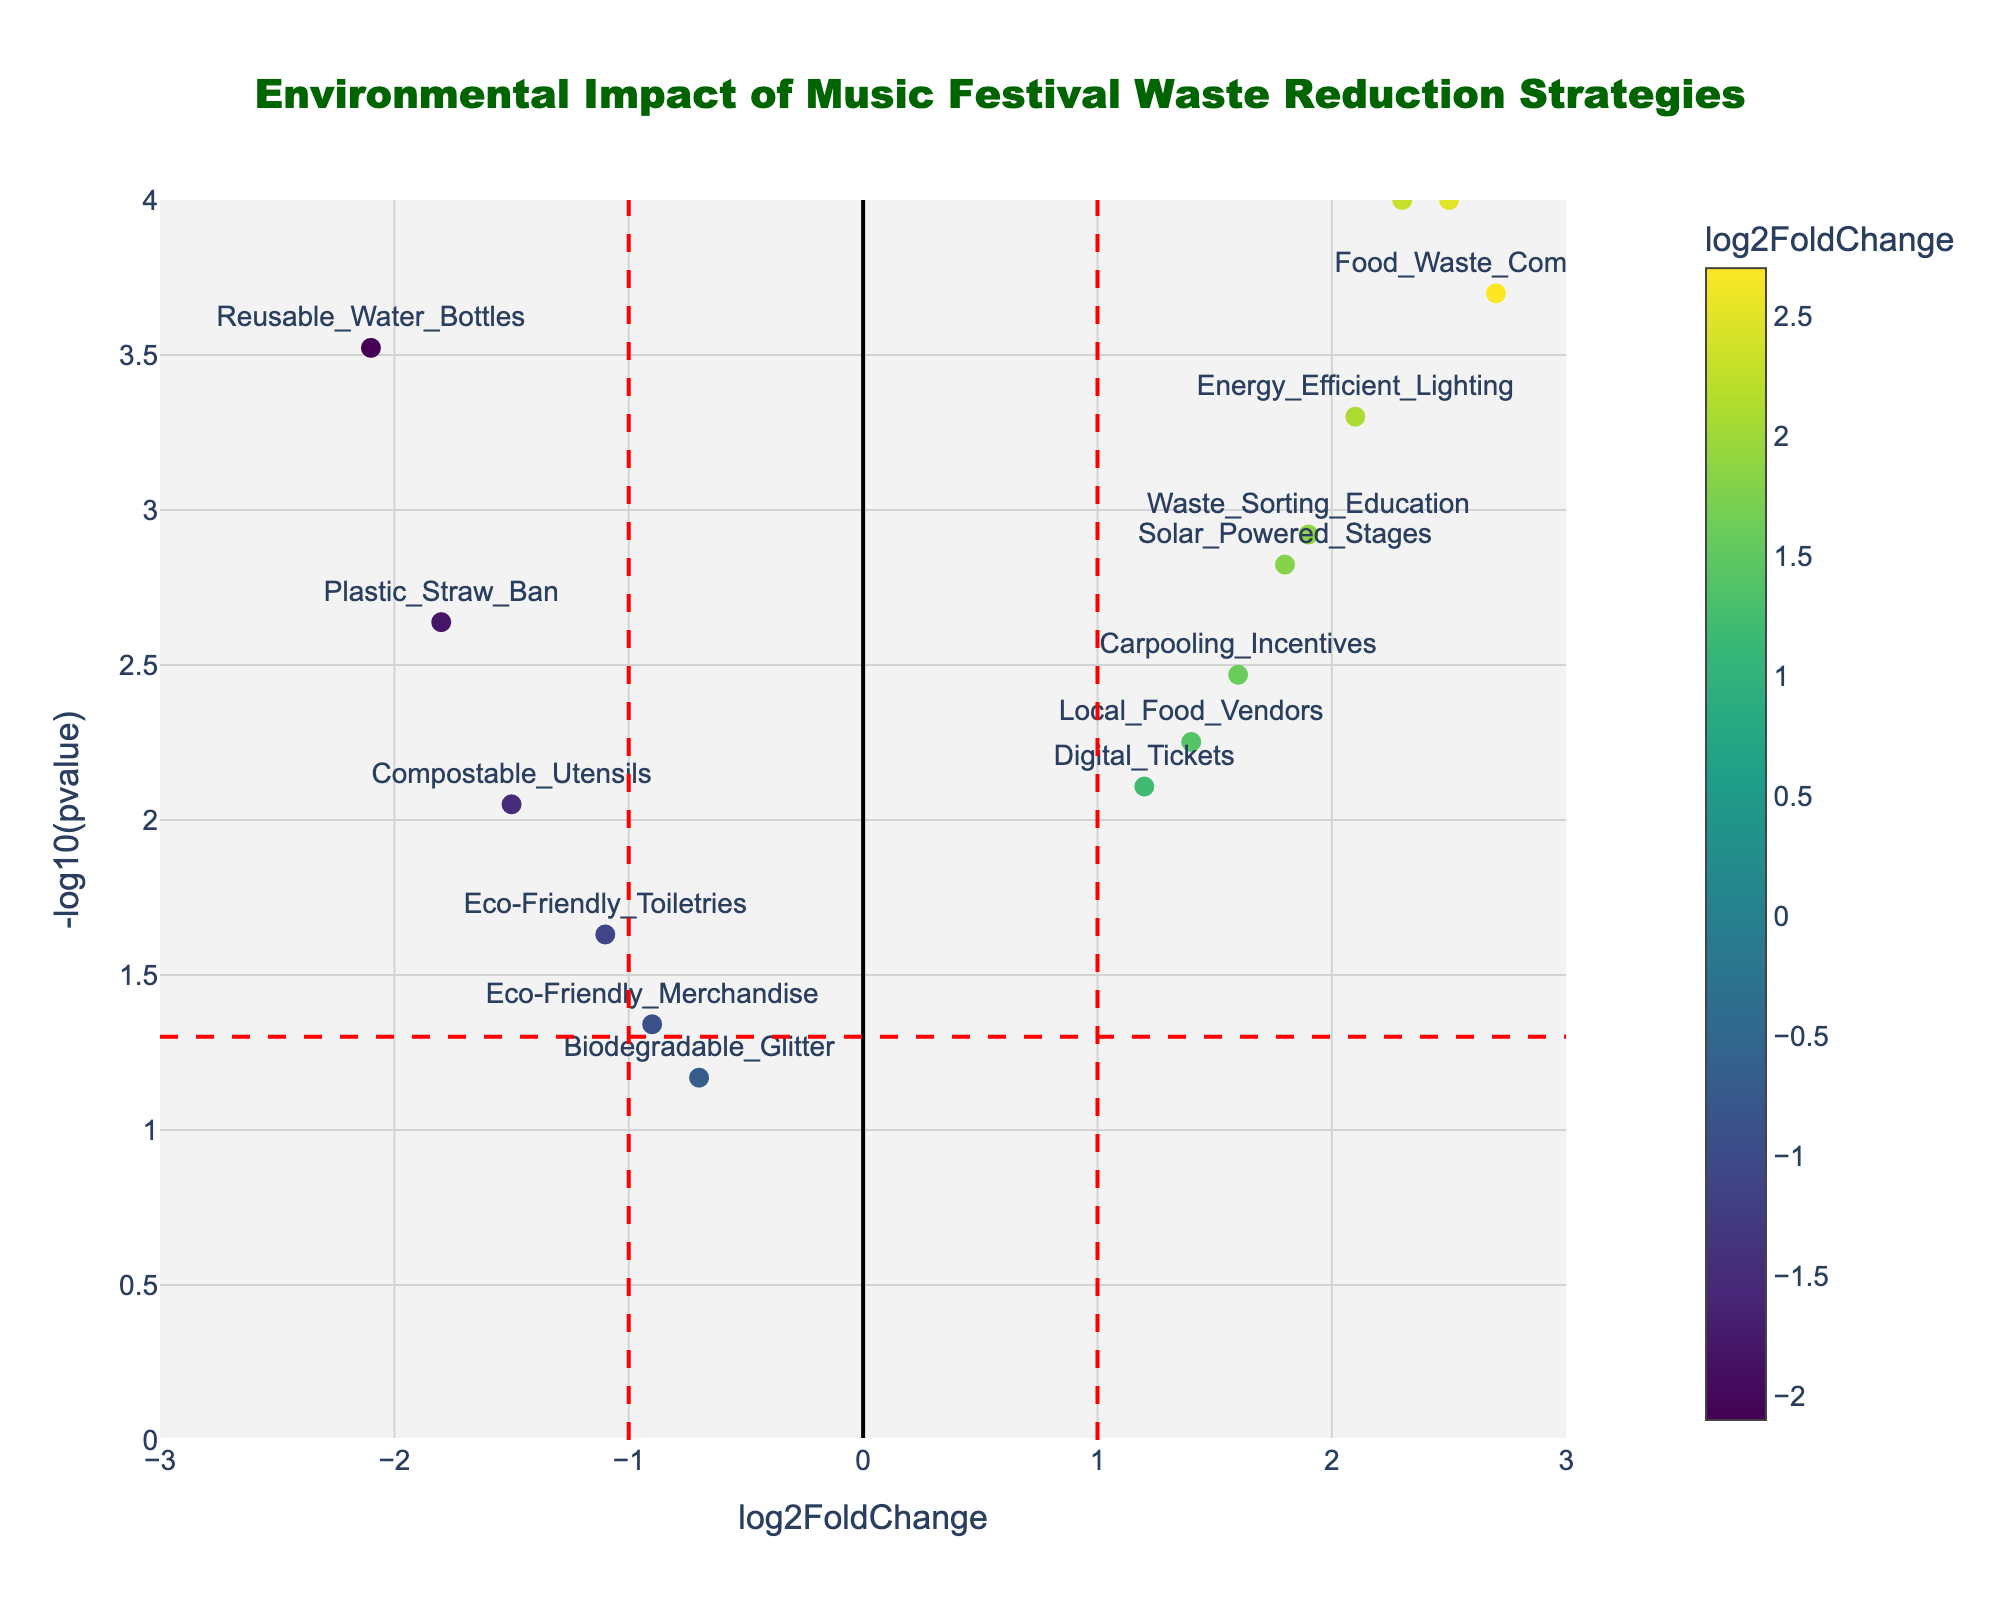What is the title of the figure? The title is prominently displayed at the top of the figure. It reads "Environmental Impact of Music Festival Waste Reduction Strategies".
Answer: Environmental Impact of Music Festival Waste Reduction Strategies What are the x-axis and y-axis labels? The x-axis is labeled "log2FoldChange" which shows the log-fold change in environmental impact, and the y-axis is labeled "-log10(pvalue)" which represents the negative logarithm of the p-value, indicating statistical significance.
Answer: x-axis: log2FoldChange, y-axis: -log10(pvalue) Which waste reduction strategy has the highest positive log2FoldChange? By examining the scatter plot, the highest positive log2FoldChange can be identified as the point farthest to the right on the x-axis. The "Food_Waste_Composting" strategy has the highest positive value.
Answer: Food_Waste_Composting What strategy has the smallest (most negative) log2FoldChange? The smallest (most negative) log2FoldChange corresponds to the point farthest to the left on the x-axis, which is labeled as "Reusable_Water_Bottles".
Answer: Reusable_Water_Bottles How many strategies are statistically significant (p-value < 0.05)? Points above the horizontal red dashed line at y = -log10(0.05) represent statistically significant strategies. Counting these points gives us the number of significant strategies. There are 13 such points.
Answer: 13 Which strategy has the lowest p-value and what is its log2FoldChange? The strategy with the lowest p-value is represented by the point highest on the y-axis. This strategy is "Recycling_Stations" with a log2FoldChange of 2.3.
Answer: Recycling_Stations, 2.3 What strategies have both a positive log2FoldChange and a p-value < 0.05? Positive log2FoldChange is defined by points to the right of x = 0, and a p-value < 0.05 is indicated by points above the horizontal dashed red line. Strategies meeting both criteria are "Recycling_Stations", "Food_Waste_Composting", "Solar_Powered_Stages", "Carpooling_Incentives", "Energy_Efficient_Lighting", "Digital_Tickets", "Waste_Sorting_Education", and "Local_Food_Vendors".
Answer: Recycling_Stations, Food_Waste_Composting, Solar_Powered_Stages, Carpooling_Incentives, Energy_Efficient_Lighting, Digital_Tickets, Waste_Sorting_Education, Local_Food_Vendors Is "Compostable_Utensils" statistically significant and what is its log2FoldChange value? "Compostable_Utensils" is statistically significant if it lies above the horizontal dashed red line which it does. Its log2FoldChange is -1.5.
Answer: Yes, -1.5 What is the log2FoldChange and -log10(pvalue) for the "Eco-Friendly_Merchandise" strategy? The position of "Eco-Friendly_Merchandise" on the plot shows its coordinates as log2FoldChange: -0.9 and -log10(pvalue): -log10(0.0456). Calculating -log10(0.0456) gives approximately 1.34.
Answer: log2FoldChange: -0.9, -log10(pvalue): 1.34 